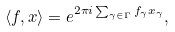<formula> <loc_0><loc_0><loc_500><loc_500>\langle f , x \rangle = e ^ { 2 \pi i \sum _ { \gamma \in \Gamma } f _ { \gamma } x _ { \gamma } } ,</formula> 